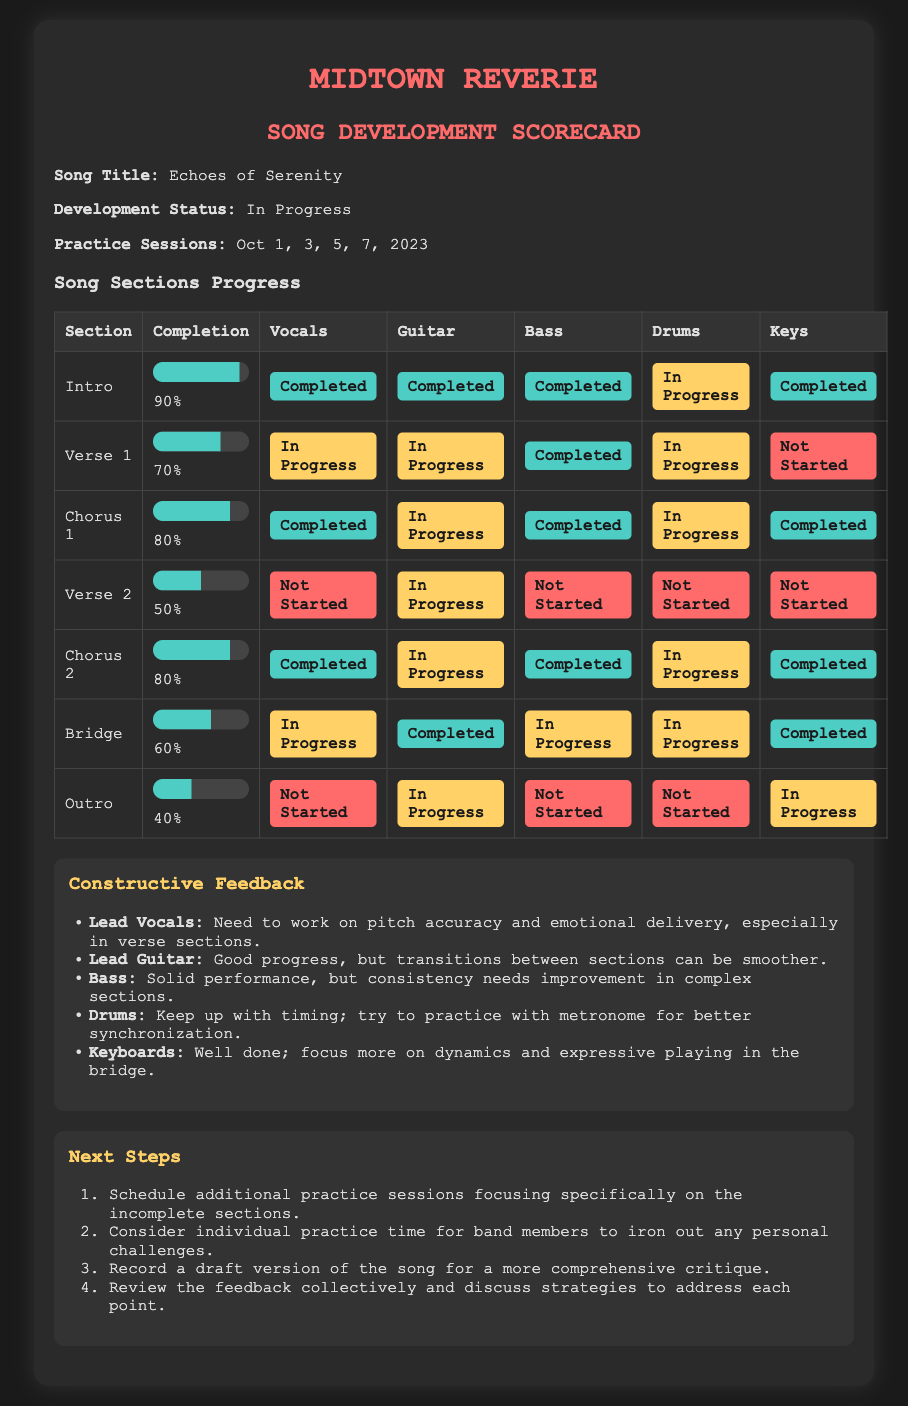What is the song title? The song title is clearly mentioned in the document.
Answer: Echoes of Serenity What is the overall development status of the song? The development status is stated to provide an update on the song's progress.
Answer: In Progress How many practice sessions were held in October 2023? The document lists the specific practice session dates to summarize the frequency of practices.
Answer: 5 What is the completion percentage of the Outro section? The completion percentage indicates how much work has been done in the Outro section.
Answer: 40% Which instrument's vocals have not started in Verse 2? The status for each instrument is provided, showing who has yet to start practicing.
Answer: Vocals What needs improvement for the Lead Vocals? Constructive feedback points out specific areas to refine the performance.
Answer: Pitch accuracy and emotional delivery How many sections have their guitar parts marked as completed? Analyzing the table helps determine the number of sections completed for guitar.
Answer: 4 What is the next step regarding individual practice? The next steps suggest actions the band should take to address challenges.
Answer: Consider individual practice time for band members 